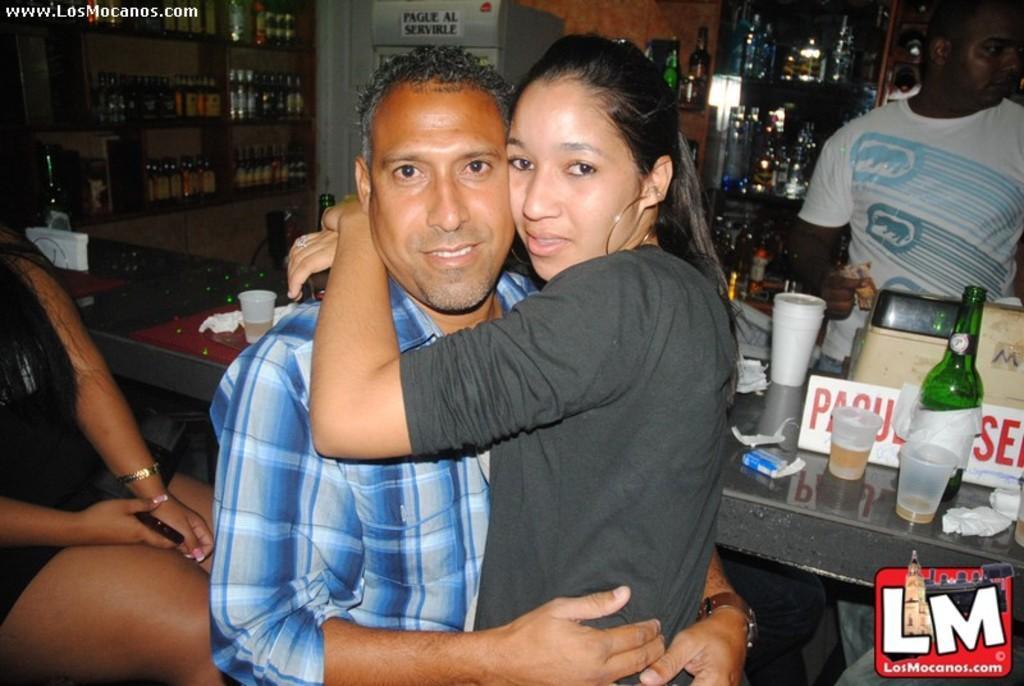Could you give a brief overview of what you see in this image? Two persons are hugging. This rack is filled with bottles. On this table there is a bottle and glasses. This woman is sitting on a chair and holding mobile. 